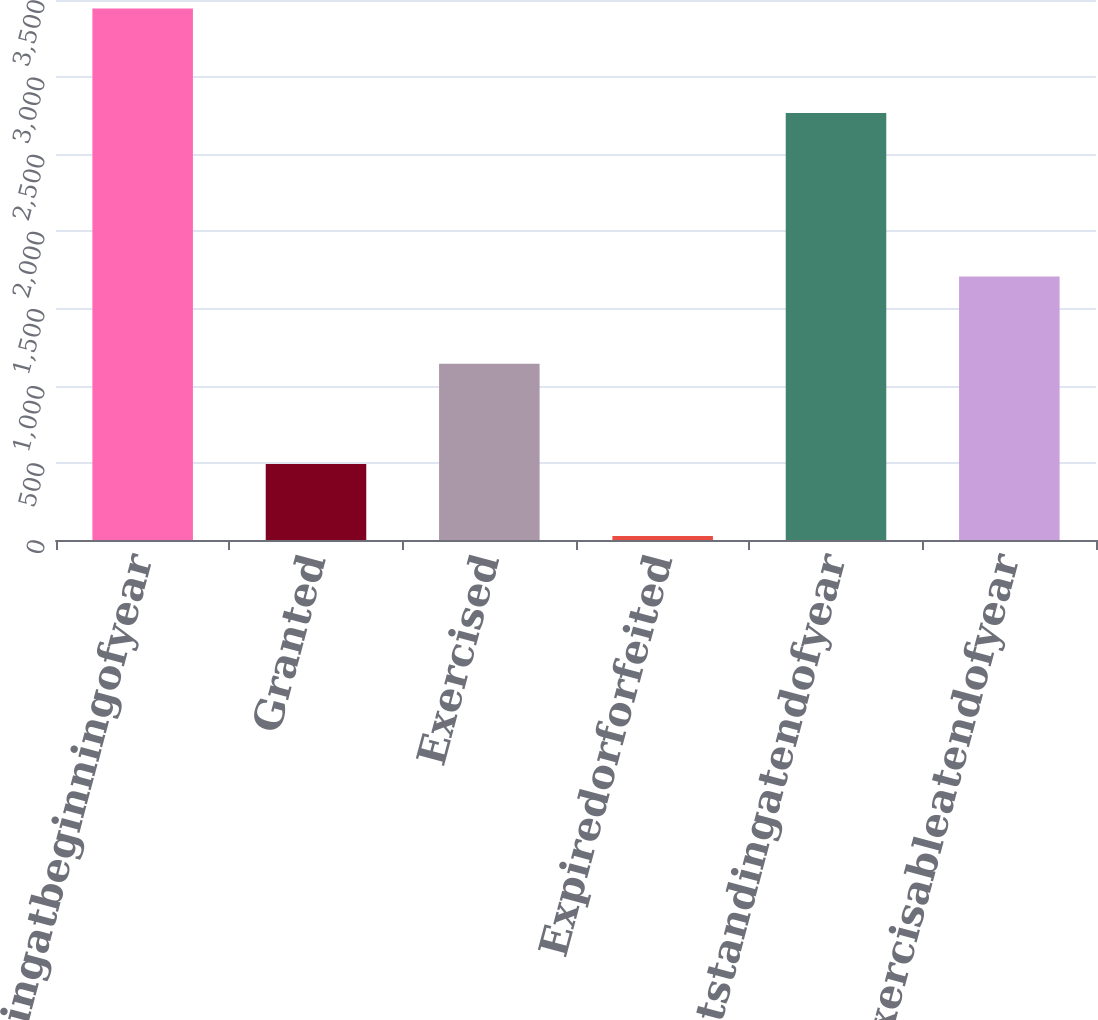Convert chart. <chart><loc_0><loc_0><loc_500><loc_500><bar_chart><fcel>Outstandingatbeginningofyear<fcel>Granted<fcel>Exercised<fcel>Expiredorforfeited<fcel>Outstandingatendofyear<fcel>Exercisableatendofyear<nl><fcel>3445<fcel>492<fcel>1143<fcel>26<fcel>2768<fcel>1708<nl></chart> 